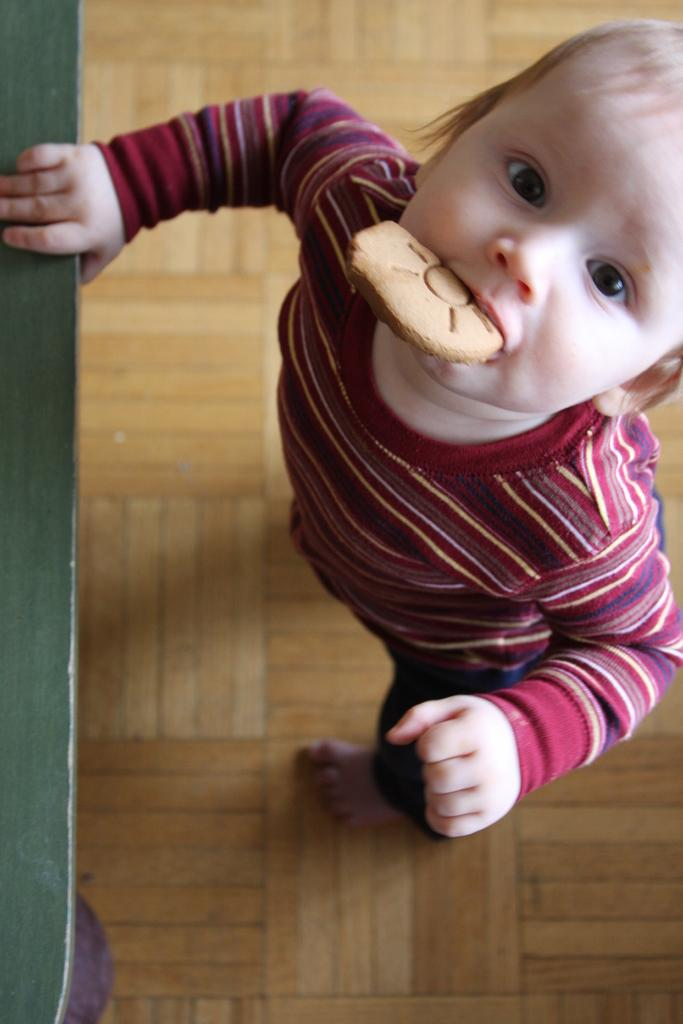What is on the right side of the image? There is a child on the right side of the image. What is the child doing in the image? The child has a biscuit in their mouth and is holding a green object in their hand. What is the child standing on in the image? The child is standing on the floor. What is the color of the background in the image? The background color is brown. Is the child sinking in quicksand in the image? No, the child is not sinking in quicksand in the image; they are standing on the floor. What type of toy is the child playing with in the image? There is no toy present in the image; the child is holding a green object, which is not specified as a toy. 